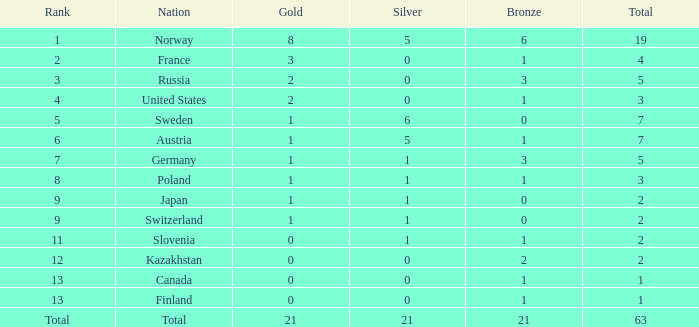What rank holds a gold below 1, and a silver exceeding 0? 11.0. 